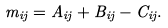<formula> <loc_0><loc_0><loc_500><loc_500>m _ { i j } = A _ { i j } + B _ { i j } - C _ { i j } .</formula> 